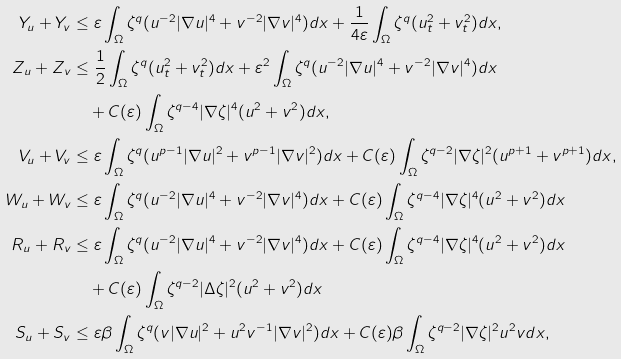Convert formula to latex. <formula><loc_0><loc_0><loc_500><loc_500>Y _ { u } + Y _ { v } & \leq \varepsilon \int _ { \Omega } \zeta ^ { q } ( u ^ { - 2 } | \nabla u | ^ { 4 } + v ^ { - 2 } | \nabla v | ^ { 4 } ) d x + \frac { 1 } { 4 \varepsilon } \int _ { \Omega } \zeta ^ { q } ( u _ { t } ^ { 2 } + v _ { t } ^ { 2 } ) d x , \\ Z _ { u } + Z _ { v } & \leq \frac { 1 } { 2 } \int _ { \Omega } \zeta ^ { q } ( u _ { t } ^ { 2 } + v _ { t } ^ { 2 } ) d x + \varepsilon ^ { 2 } \int _ { \Omega } \zeta ^ { q } ( u ^ { - 2 } | \nabla u | ^ { 4 } + v ^ { - 2 } | \nabla v | ^ { 4 } ) d x \\ & \quad + C ( \varepsilon ) \int _ { \Omega } \zeta ^ { q - 4 } | \nabla \zeta | ^ { 4 } ( u ^ { 2 } + v ^ { 2 } ) d x , \\ V _ { u } + V _ { v } & \leq \varepsilon \int _ { \Omega } \zeta ^ { q } ( u ^ { p - 1 } | \nabla u | ^ { 2 } + v ^ { p - 1 } | \nabla v | ^ { 2 } ) d x + C ( \varepsilon ) \int _ { \Omega } \zeta ^ { q - 2 } | \nabla \zeta | ^ { 2 } ( u ^ { p + 1 } + v ^ { p + 1 } ) d x , \\ W _ { u } + W _ { v } & \leq \varepsilon \int _ { \Omega } \zeta ^ { q } ( u ^ { - 2 } | \nabla u | ^ { 4 } + v ^ { - 2 } | \nabla v | ^ { 4 } ) d x + C ( \varepsilon ) \int _ { \Omega } \zeta ^ { q - 4 } | \nabla \zeta | ^ { 4 } ( u ^ { 2 } + v ^ { 2 } ) d x \\ R _ { u } + R _ { v } & \leq \varepsilon \int _ { \Omega } \zeta ^ { q } ( u ^ { - 2 } | \nabla u | ^ { 4 } + v ^ { - 2 } | \nabla v | ^ { 4 } ) d x + C ( \varepsilon ) \int _ { \Omega } \zeta ^ { q - 4 } | \nabla \zeta | ^ { 4 } ( u ^ { 2 } + v ^ { 2 } ) d x \\ & \quad + C ( \varepsilon ) \int _ { \Omega } \zeta ^ { q - 2 } | \Delta \zeta | ^ { 2 } ( u ^ { 2 } + v ^ { 2 } ) d x \\ S _ { u } + S _ { v } & \leq \varepsilon \beta \int _ { \Omega } \zeta ^ { q } ( v | \nabla u | ^ { 2 } + u ^ { 2 } v ^ { - 1 } | \nabla v | ^ { 2 } ) d x + C ( \varepsilon ) \beta \int _ { \Omega } \zeta ^ { q - 2 } | \nabla \zeta | ^ { 2 } u ^ { 2 } v d x ,</formula> 